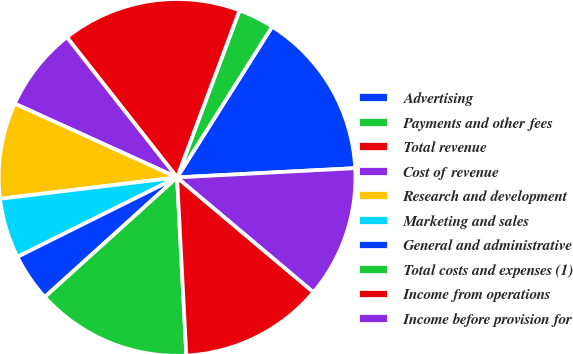<chart> <loc_0><loc_0><loc_500><loc_500><pie_chart><fcel>Advertising<fcel>Payments and other fees<fcel>Total revenue<fcel>Cost of revenue<fcel>Research and development<fcel>Marketing and sales<fcel>General and administrative<fcel>Total costs and expenses (1)<fcel>Income from operations<fcel>Income before provision for<nl><fcel>15.22%<fcel>3.26%<fcel>16.3%<fcel>7.61%<fcel>8.7%<fcel>5.44%<fcel>4.35%<fcel>14.13%<fcel>13.04%<fcel>11.96%<nl></chart> 